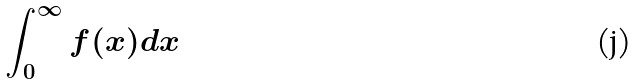<formula> <loc_0><loc_0><loc_500><loc_500>\int _ { 0 } ^ { \infty } f ( x ) d x</formula> 